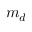<formula> <loc_0><loc_0><loc_500><loc_500>m _ { d }</formula> 